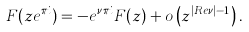<formula> <loc_0><loc_0><loc_500><loc_500>F ( z e ^ { \pi i } ) = - e ^ { \nu \pi i } F ( z ) + o \left ( z ^ { | { R e } \nu | - 1 } \right ) .</formula> 